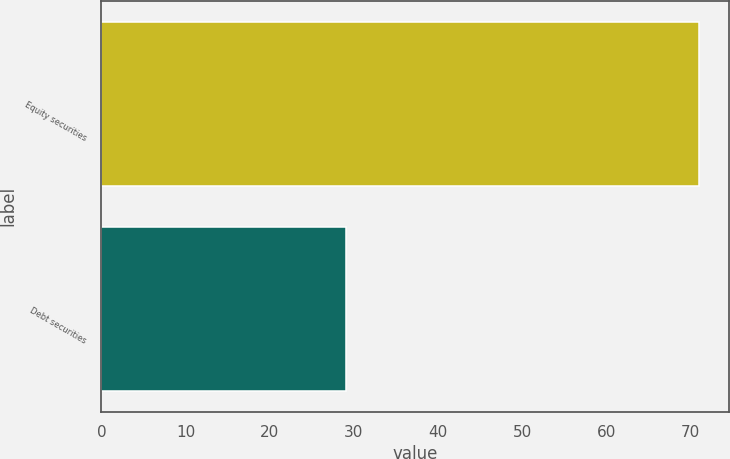Convert chart to OTSL. <chart><loc_0><loc_0><loc_500><loc_500><bar_chart><fcel>Equity securities<fcel>Debt securities<nl><fcel>71<fcel>29<nl></chart> 